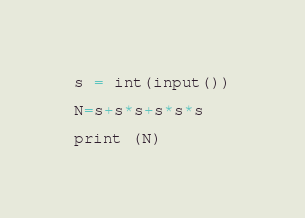<code> <loc_0><loc_0><loc_500><loc_500><_Python_>s = int(input())
 
N=s+s*s+s*s*s
 
print (N)</code> 